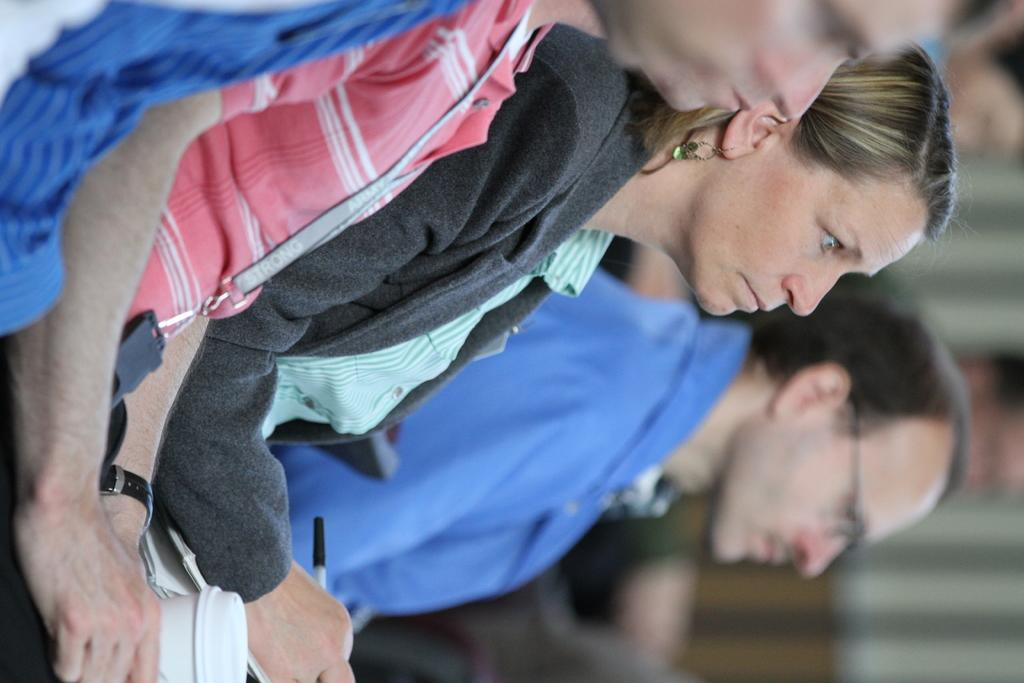What is the main focus of the image? The main focus of the image is the people in the center. What object can be seen at the bottom side of the image? There is a glass at the bottom side of the image. Can you describe the area behind the main subjects in the image? There is a background area in the image. How many cakes are being served by the dinosaurs in the image? There are no dinosaurs or cakes present in the image. 